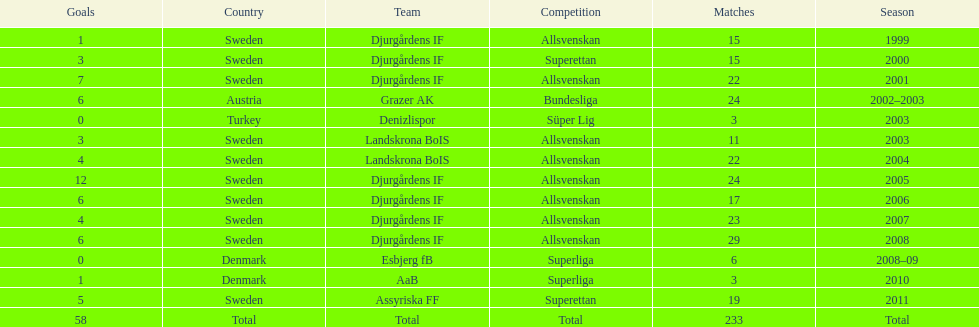How many matches overall were there? 233. 